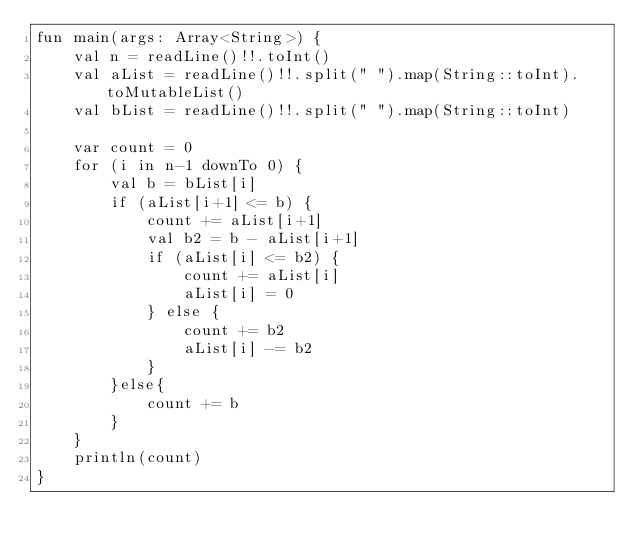Convert code to text. <code><loc_0><loc_0><loc_500><loc_500><_Kotlin_>fun main(args: Array<String>) {
    val n = readLine()!!.toInt()
    val aList = readLine()!!.split(" ").map(String::toInt).toMutableList()
    val bList = readLine()!!.split(" ").map(String::toInt)

    var count = 0
    for (i in n-1 downTo 0) {
        val b = bList[i]
        if (aList[i+1] <= b) {
            count += aList[i+1]
            val b2 = b - aList[i+1]
            if (aList[i] <= b2) {
                count += aList[i]
                aList[i] = 0
            } else {
                count += b2
                aList[i] -= b2
            }
        }else{
            count += b
        }
    }
    println(count)
}</code> 